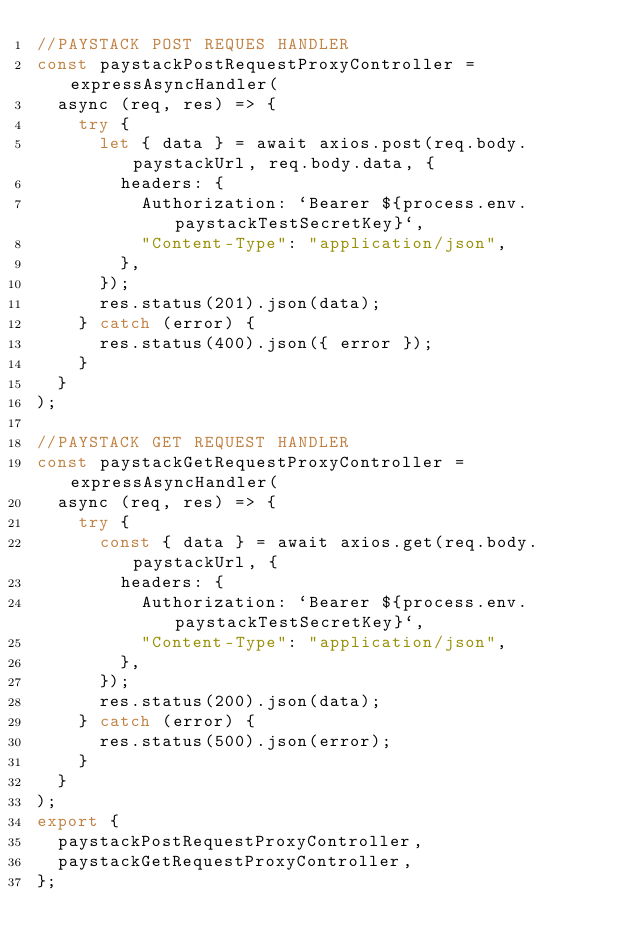Convert code to text. <code><loc_0><loc_0><loc_500><loc_500><_JavaScript_>//PAYSTACK POST REQUES HANDLER
const paystackPostRequestProxyController = expressAsyncHandler(
  async (req, res) => {
    try {
      let { data } = await axios.post(req.body.paystackUrl, req.body.data, {
        headers: {
          Authorization: `Bearer ${process.env.paystackTestSecretKey}`,
          "Content-Type": "application/json",
        },
      });
      res.status(201).json(data);
    } catch (error) {
      res.status(400).json({ error });
    }
  }
);

//PAYSTACK GET REQUEST HANDLER
const paystackGetRequestProxyController = expressAsyncHandler(
  async (req, res) => {
    try {
      const { data } = await axios.get(req.body.paystackUrl, {
        headers: {
          Authorization: `Bearer ${process.env.paystackTestSecretKey}`,
          "Content-Type": "application/json",
        },
      });
      res.status(200).json(data);
    } catch (error) {
      res.status(500).json(error);
    }
  }
);
export {
  paystackPostRequestProxyController,
  paystackGetRequestProxyController,
};
</code> 